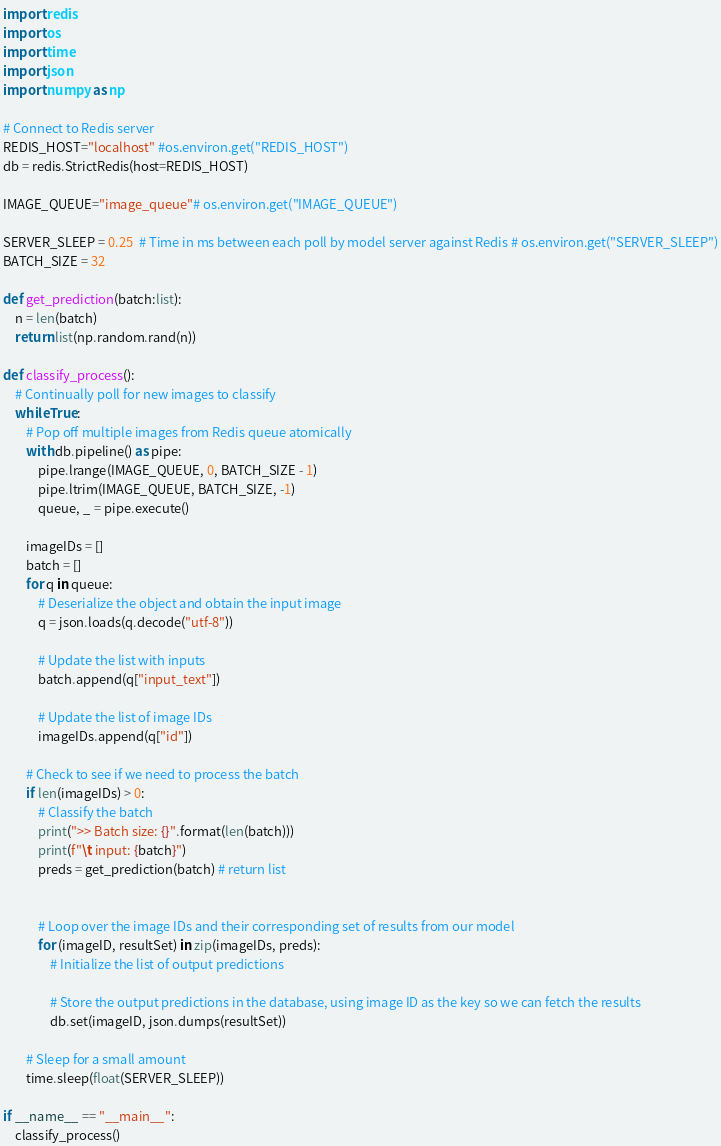<code> <loc_0><loc_0><loc_500><loc_500><_Python_>import redis
import os
import time
import json 
import numpy as np

# Connect to Redis server
REDIS_HOST="localhost" #os.environ.get("REDIS_HOST")
db = redis.StrictRedis(host=REDIS_HOST)

IMAGE_QUEUE="image_queue"# os.environ.get("IMAGE_QUEUE")

SERVER_SLEEP = 0.25  # Time in ms between each poll by model server against Redis # os.environ.get("SERVER_SLEEP")
BATCH_SIZE = 32

def get_prediction(batch:list):
    n = len(batch)
    return list(np.random.rand(n))

def classify_process():
    # Continually poll for new images to classify
    while True:
        # Pop off multiple images from Redis queue atomically
        with db.pipeline() as pipe:
            pipe.lrange(IMAGE_QUEUE, 0, BATCH_SIZE - 1)
            pipe.ltrim(IMAGE_QUEUE, BATCH_SIZE, -1)
            queue, _ = pipe.execute()

        imageIDs = []
        batch = []
        for q in queue:
            # Deserialize the object and obtain the input image
            q = json.loads(q.decode("utf-8"))
            
            # Update the list with inputs
            batch.append(q["input_text"])

            # Update the list of image IDs
            imageIDs.append(q["id"])

        # Check to see if we need to process the batch
        if len(imageIDs) > 0:
            # Classify the batch
            print(">> Batch size: {}".format(len(batch)))
            print(f"\t input: {batch}")
            preds = get_prediction(batch) # return list 
            

            # Loop over the image IDs and their corresponding set of results from our model
            for (imageID, resultSet) in zip(imageIDs, preds):
                # Initialize the list of output predictions
                
                # Store the output predictions in the database, using image ID as the key so we can fetch the results
                db.set(imageID, json.dumps(resultSet))

        # Sleep for a small amount
        time.sleep(float(SERVER_SLEEP))

if __name__ == "__main__":
    classify_process()
</code> 